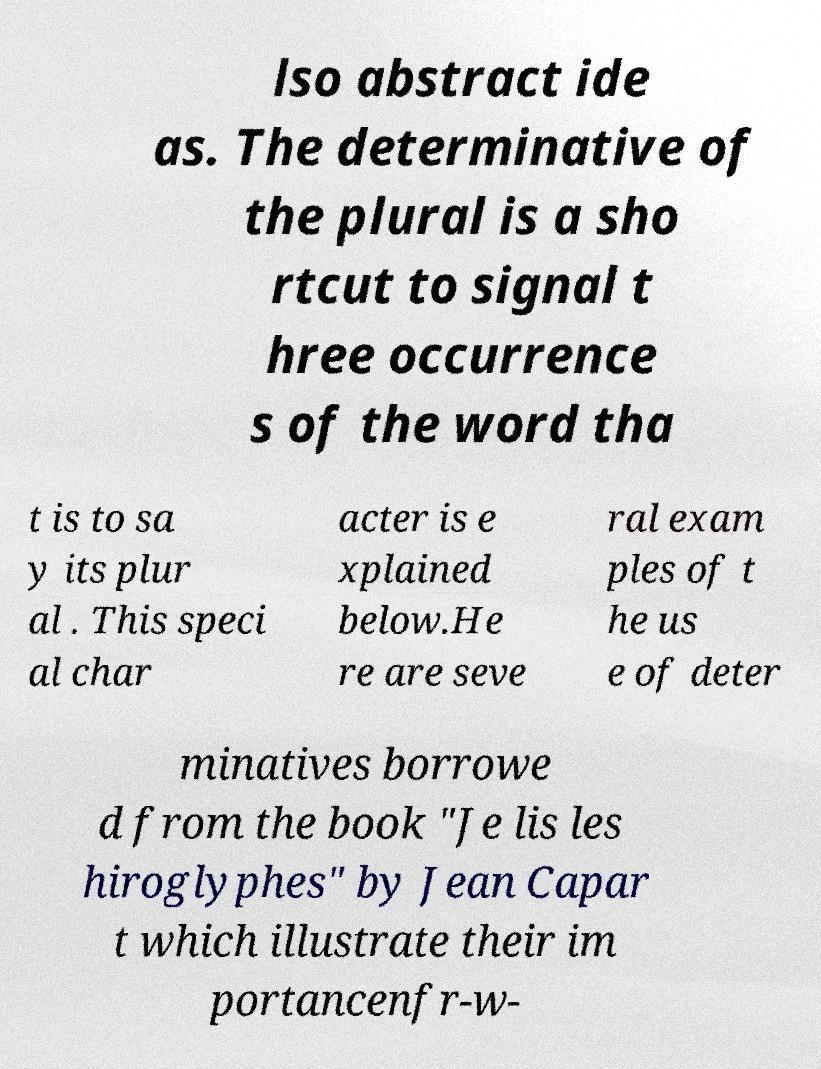Could you extract and type out the text from this image? lso abstract ide as. The determinative of the plural is a sho rtcut to signal t hree occurrence s of the word tha t is to sa y its plur al . This speci al char acter is e xplained below.He re are seve ral exam ples of t he us e of deter minatives borrowe d from the book "Je lis les hiroglyphes" by Jean Capar t which illustrate their im portancenfr-w- 